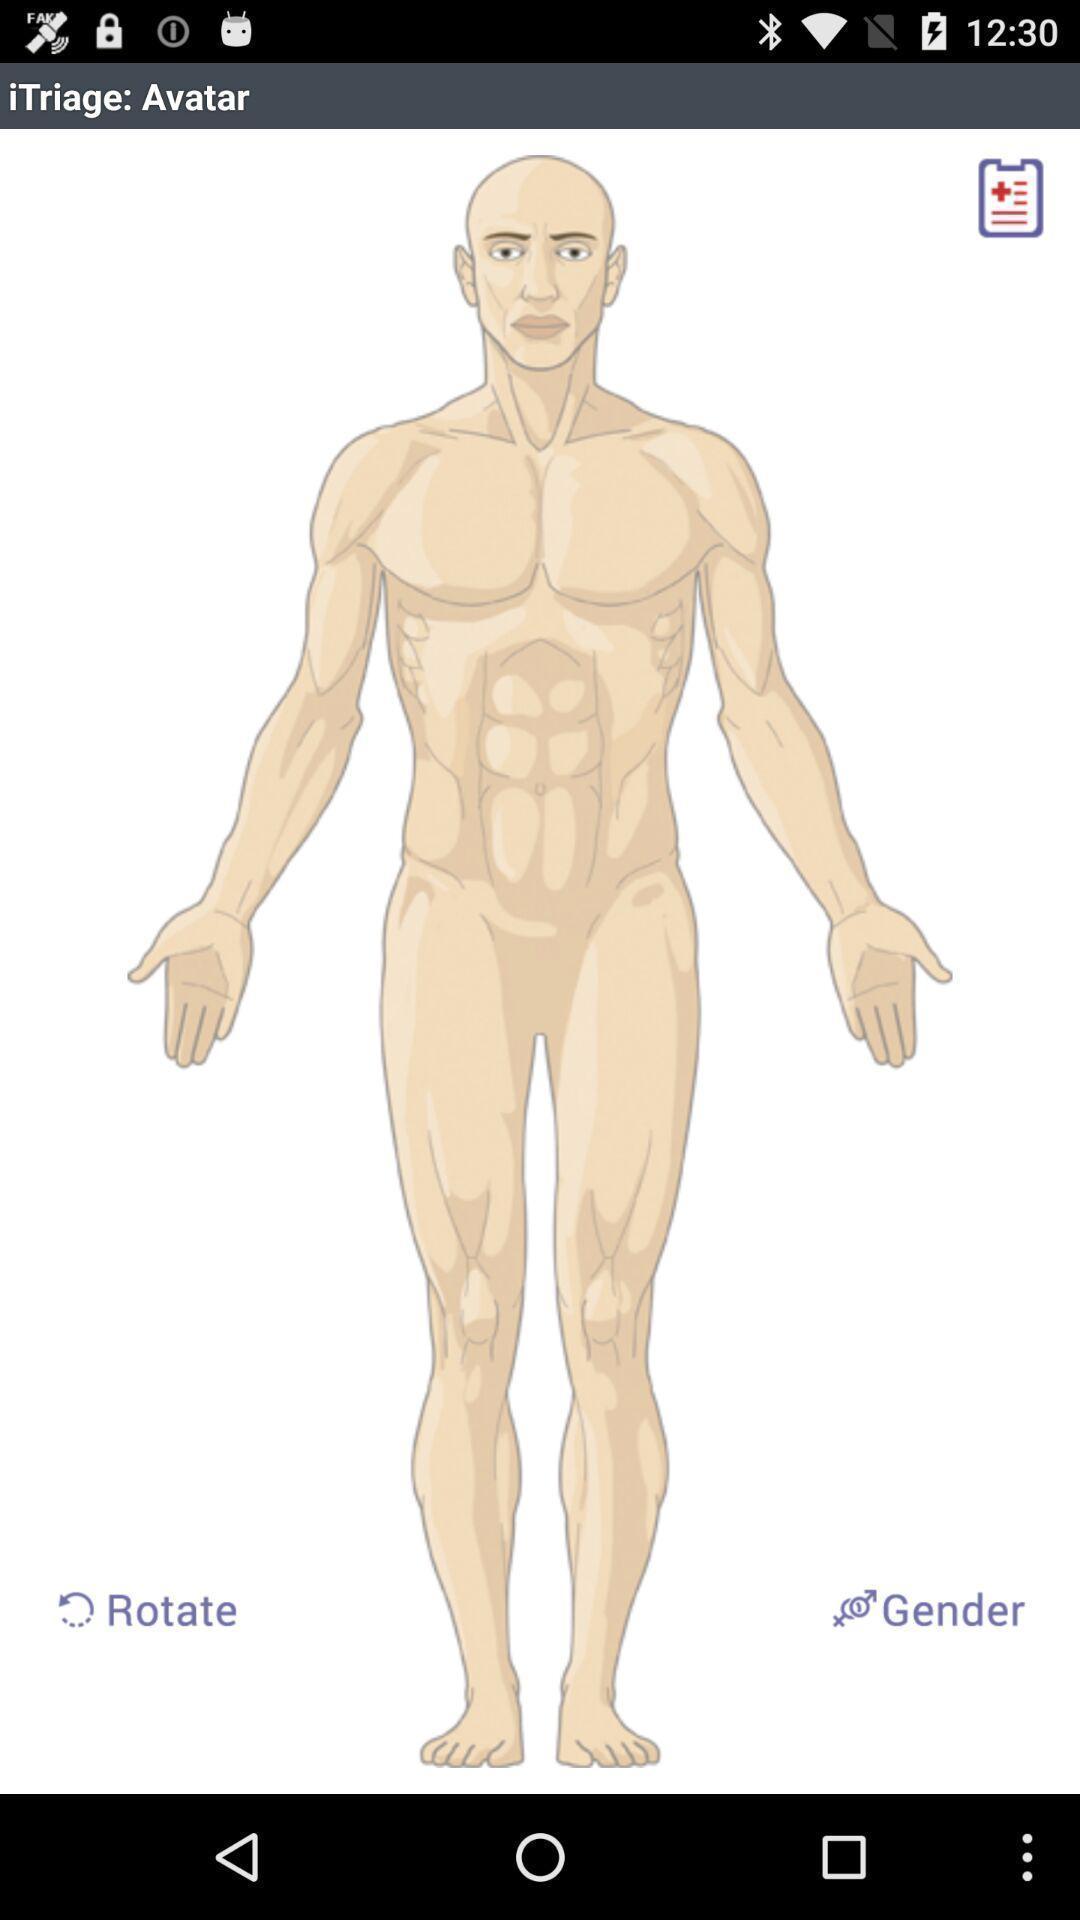Tell me what you see in this picture. Screen displaying multiple control options and a human picture. 